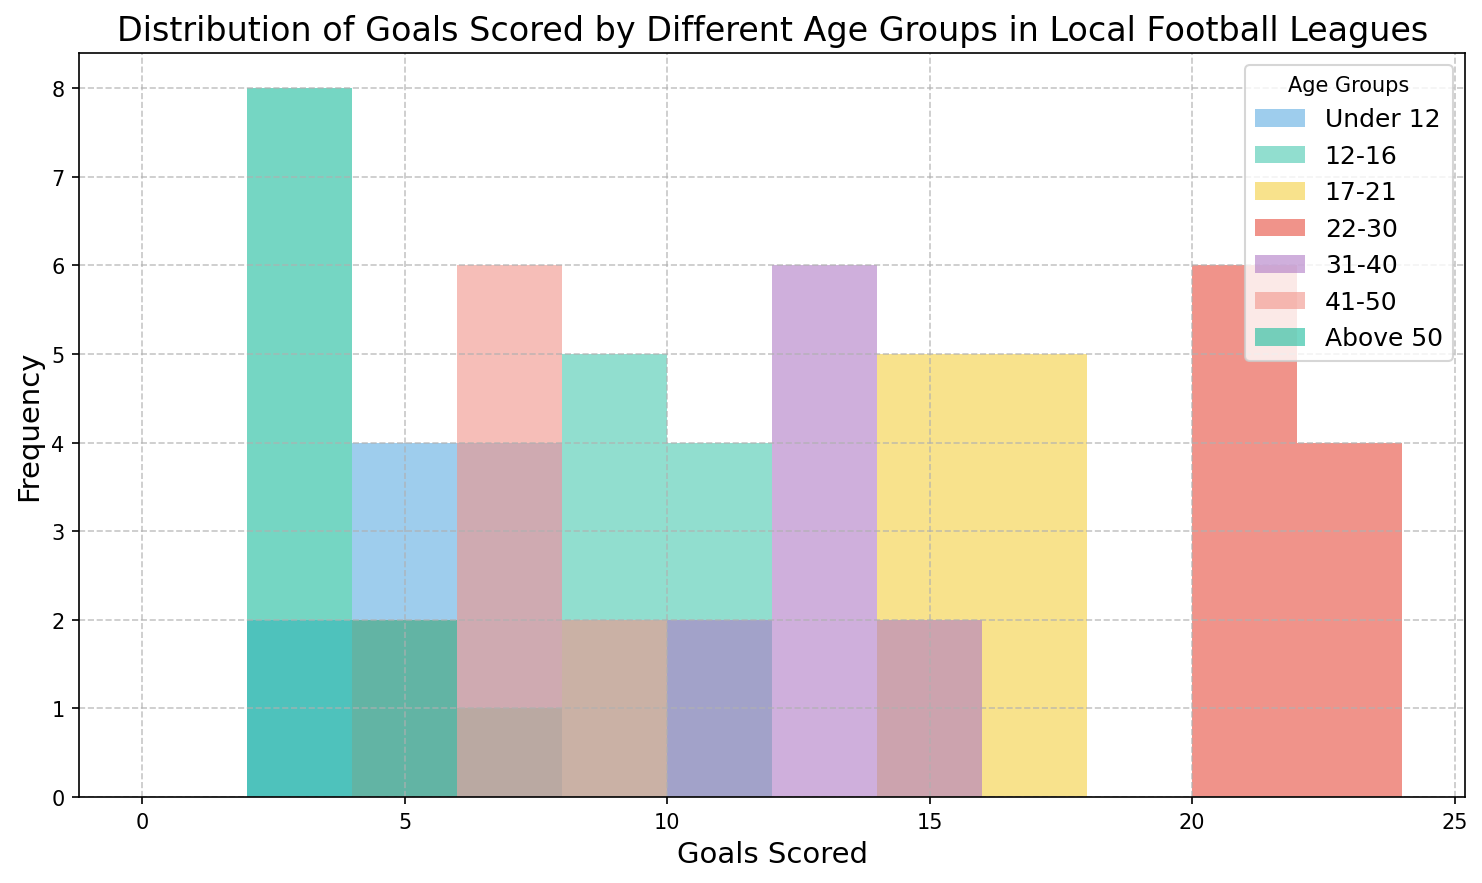Which age group has the highest number of goals in the "12-14" range? By examining the figure's histogram, identify the age group that has bars in the "12-14" range and compare their heights to determine which one has the highest frequency.
Answer: 31-40 Which age group has the widest range of goals scored? To find the widest range, look at the spread of bars for each age group and identify the group that covers the largest interval of goals scored. Compare the ranges visually.
Answer: 22-30 What is the most frequently scored number of goals for the "Under 12" group? Check the heights of the bars corresponding to the "Under 12" age group and identify the value on the x-axis that aligns with the tallest bar.
Answer: 5 and 6 Which age groups score more than 10 goals? Look at the segments of the histogram beyond the 10 goals mark and note the age groups that have bars present in this region.
Answer: 17-21, 22-30, and 31-40 Compare the frequency of 7 goals scored between "12-16" and "41-50" age groups. Who scores more frequently? Examine the heights of the bars corresponding to 7 goals scored for the "12-16" and "41-50" age groups and compare their heights to determine which is taller.
Answer: 41-50 Is there any age group that does not score more than 10 goals? Identify age groups and check if there are any bars for them that reach beyond the 10 goals mark in the histogram.
Answer: Under 12, 41-50, and Above 50 What is the mode of goals scored by the "17-21" age group? Identify the number of goals corresponding to the tallest bar for the "17-21" age group and verify which value of goals scored appears most frequently.
Answer: 15 and 16 How does the frequency of scoring 8-10 goals compare between the "12-16" and "31-40" age groups? Examine the heights of the bars between 8 and 10 goals for both age groups and determine which one has taller bars, indicating higher frequency.
Answer: 12-16 What is the median number of goals scored by the "Above 50" age group? To find the median, align the values in ascending order (2, 2, 3, 3, 3, 3, 3, 3, 4, 4) and identify the middle value. Since there are 10 values, the median would be the average of the 5th and 6th values (both are 3).
Answer: 3 Which age group predominantly scores between 20-23 goals? Look at the bars within the 20-23 goals range and identify the age group that has the highest bars in this interval.
Answer: 22-30 